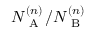<formula> <loc_0><loc_0><loc_500><loc_500>N _ { A } ^ { ( n ) } / N _ { B } ^ { ( n ) }</formula> 